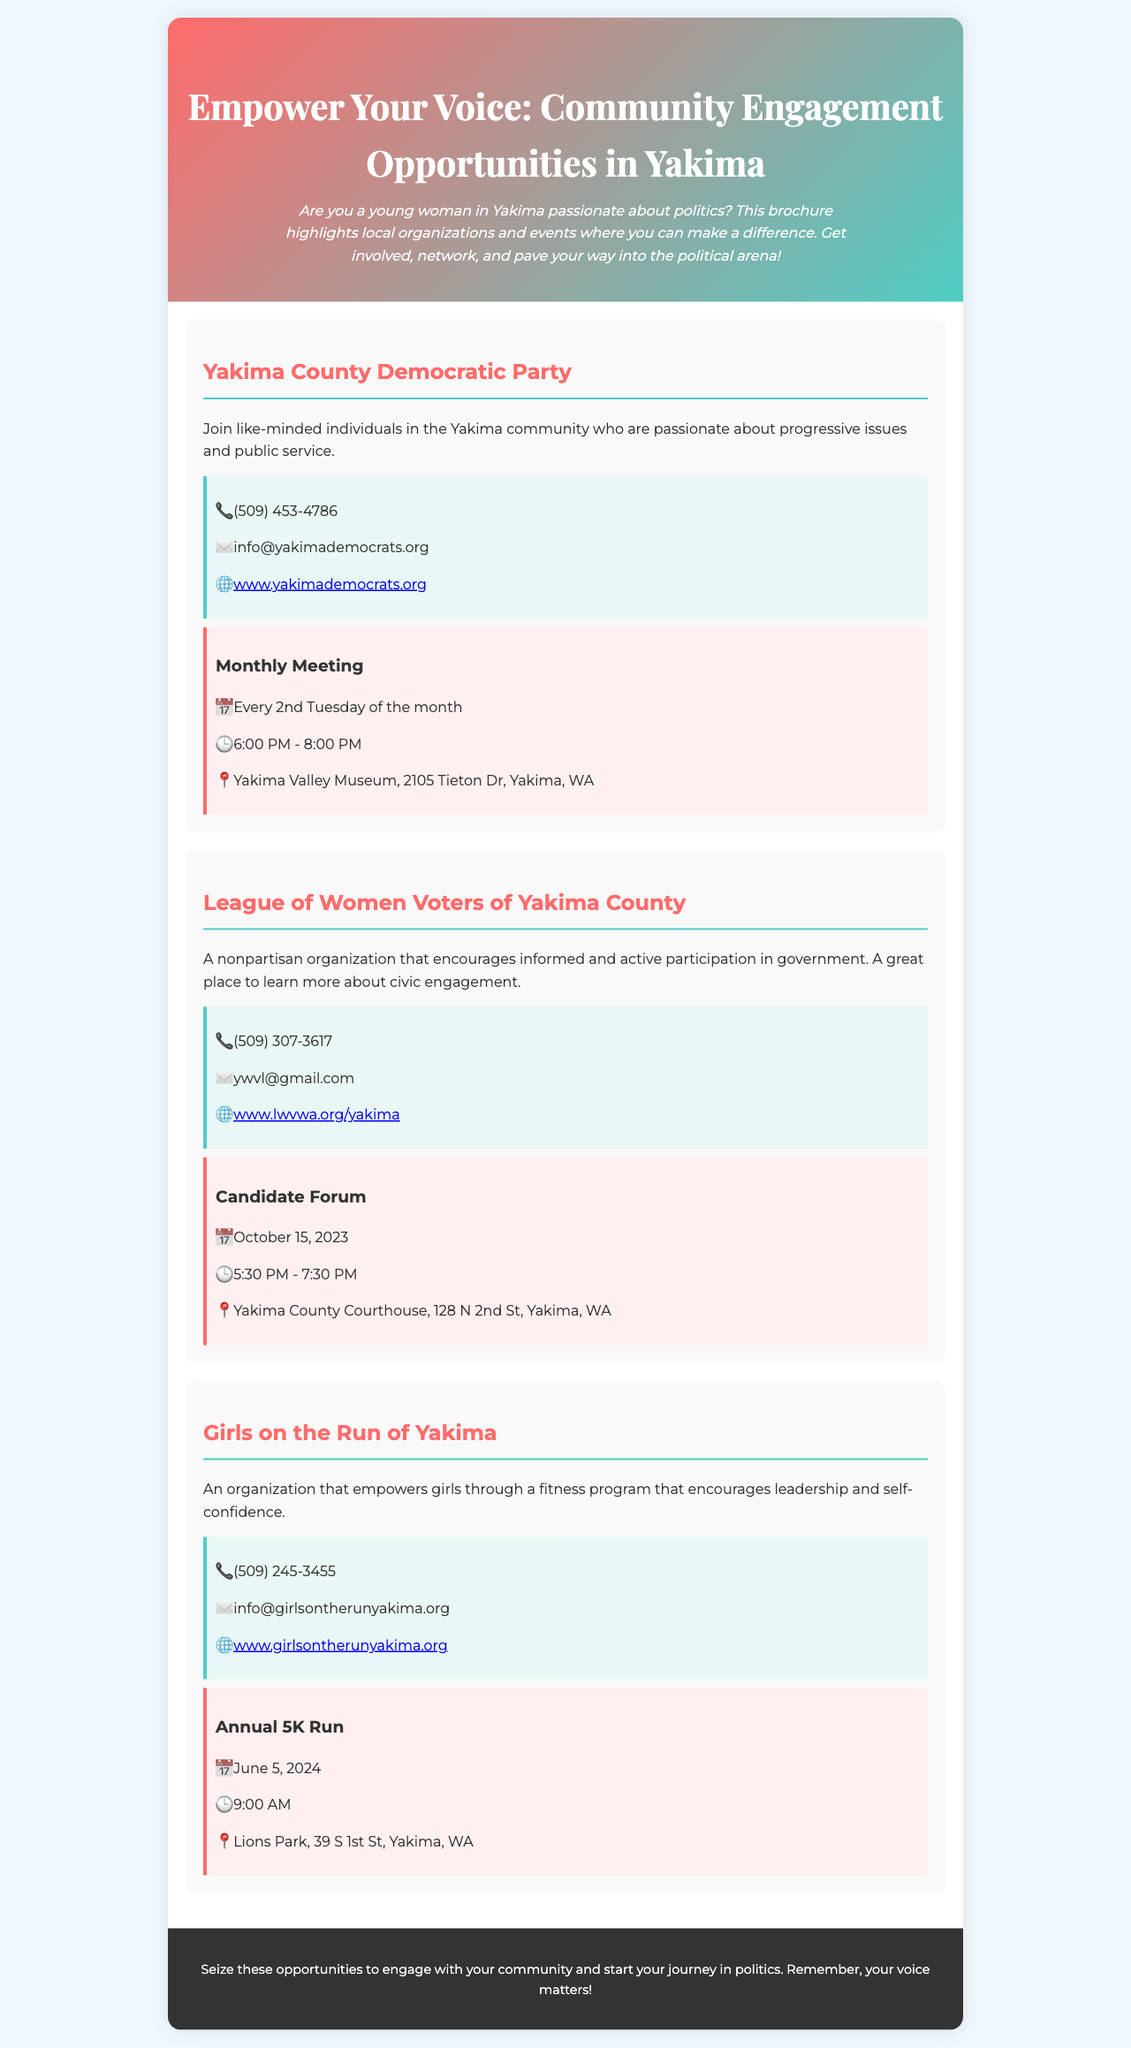What is the title of the brochure? The title of the brochure is prominently displayed at the top of the document.
Answer: Empower Your Voice: Community Engagement Opportunities in Yakima What organization holds meetings every 2nd Tuesday of the month? The organization that meets every 2nd Tuesday can be found in the event section of the Yakima County Democratic Party.
Answer: Yakima County Democratic Party When is the Candidate Forum scheduled? The specific date of the event is listed under the League of Women Voters of Yakima County.
Answer: October 15, 2023 What is the contact email for Girls on the Run of Yakima? The email address provided is listed in the contact information section of the Girls on the Run of Yakima.
Answer: info@girlsontherunyakima.org Where does the Annual 5K Run take place? The location of the event can be found in the details listed under the Girls on the Run of Yakima section.
Answer: Lions Park, 39 S 1st St, Yakima, WA Which organization encourages informed participation in government? The description of the organization highlights its mission regarding civic engagement.
Answer: League of Women Voters of Yakima County How many organizations are mentioned in the brochure? The count of organizations listed in the document can be identified in the main content section.
Answer: Three 